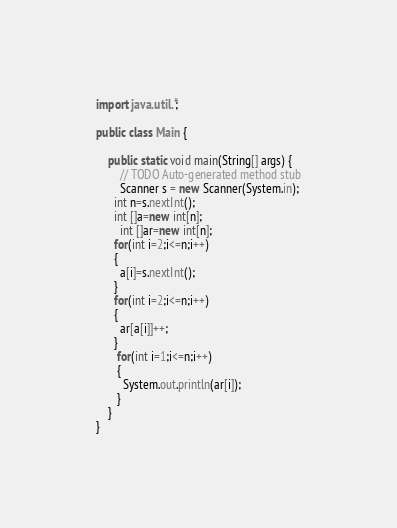<code> <loc_0><loc_0><loc_500><loc_500><_Java_>import java.util.*;
 
public class Main {
 
	public static void main(String[] args) {
		// TODO Auto-generated method stub
		Scanner s = new Scanner(System.in);
      int n=s.nextInt();
      int []a=new int[n];
        int []ar=new int[n];
      for(int i=2;i<=n;i++)
      {
        a[i]=s.nextInt();
      }
      for(int i=2;i<=n;i++)
      {
        ar[a[i]]++;
      }
       for(int i=1;i<=n;i++)
       {
         System.out.println(ar[i]);
       }
    }
}
</code> 